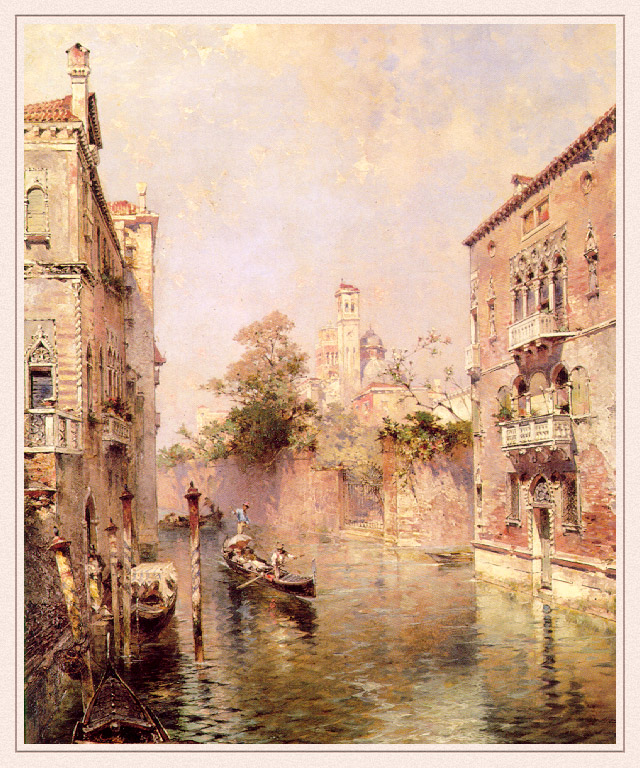If this image were part of a movie, what might the plot be? If this image were part of a movie, it could be a romantic drama set in the heart of Venice. The story could follow two protagonists who meet by chance during the annual Carnival of Venice. As they explore the city's winding canals and historic streets, their relationship deepens, and they discover hidden secrets about Venice's past and their intertwined destinities. The plot might involve solving a historical mystery connected to one of the grand buildings captured in the image, leading them on a treasure hunt filled with adventure and intrigue. As they uncover more about the city's history, their bond strengthens, ultimately leading to a heartfelt conclusion where they must decide between pursuing their individual paths or embarking on a new journey together. What would be an unexpected twist in this movie? An unexpected twist in this romantic drama could be the revelation that one of the protagonists is actually a descendant of a long-lost Venetian noble family. This newly discovered heritage could provide them with clues that not only solve the historical mystery but also uncover a hidden family fortune and a centuries-old feud. This twist could add layers of complexity to the storyline, as the protagonists navigate their newfound connection to Venice's rich history while dealing with the modern implications of their discovery. The plot could culminate in a dramatic confrontation where past loyalties and contemporary relationships collide, forcing the characters to make life-altering decisions. 